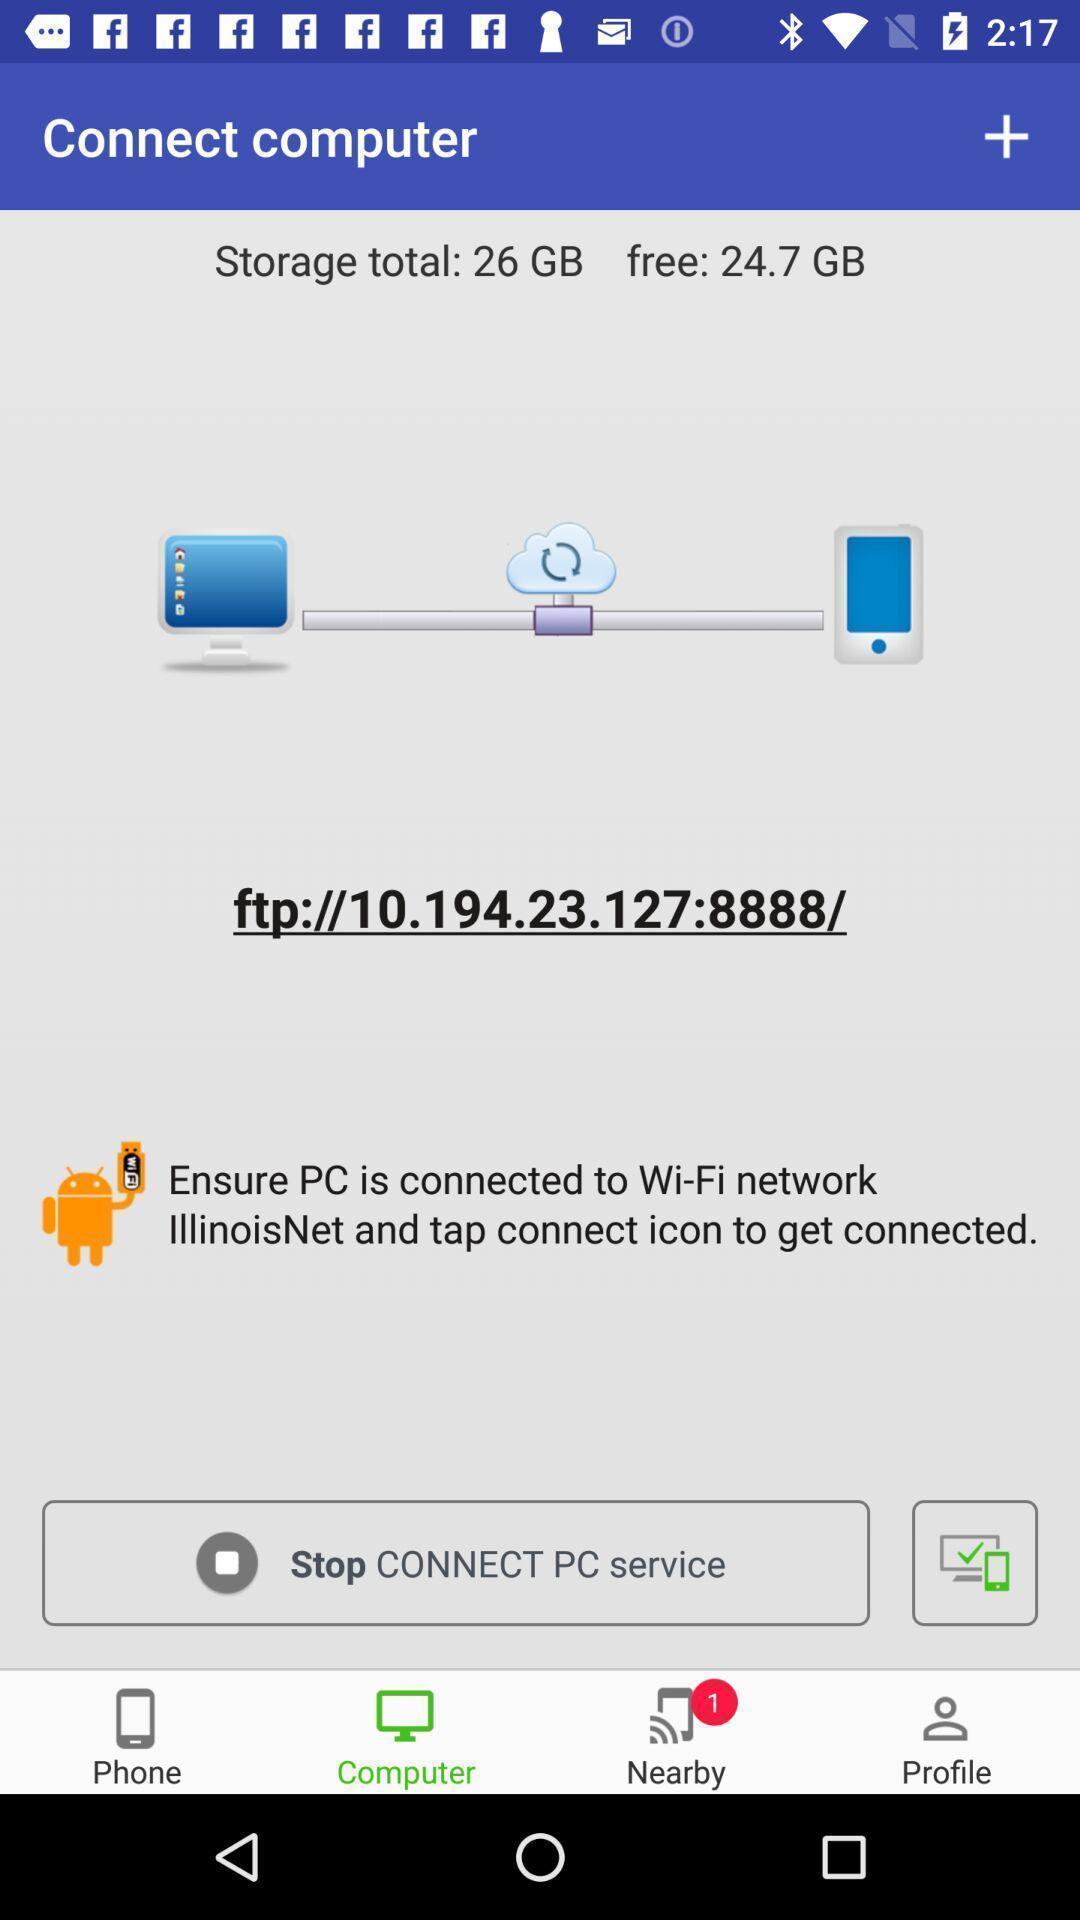Explain the elements present in this screenshot. Storage details and features of data transferring app. 